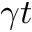<formula> <loc_0><loc_0><loc_500><loc_500>\gamma t</formula> 